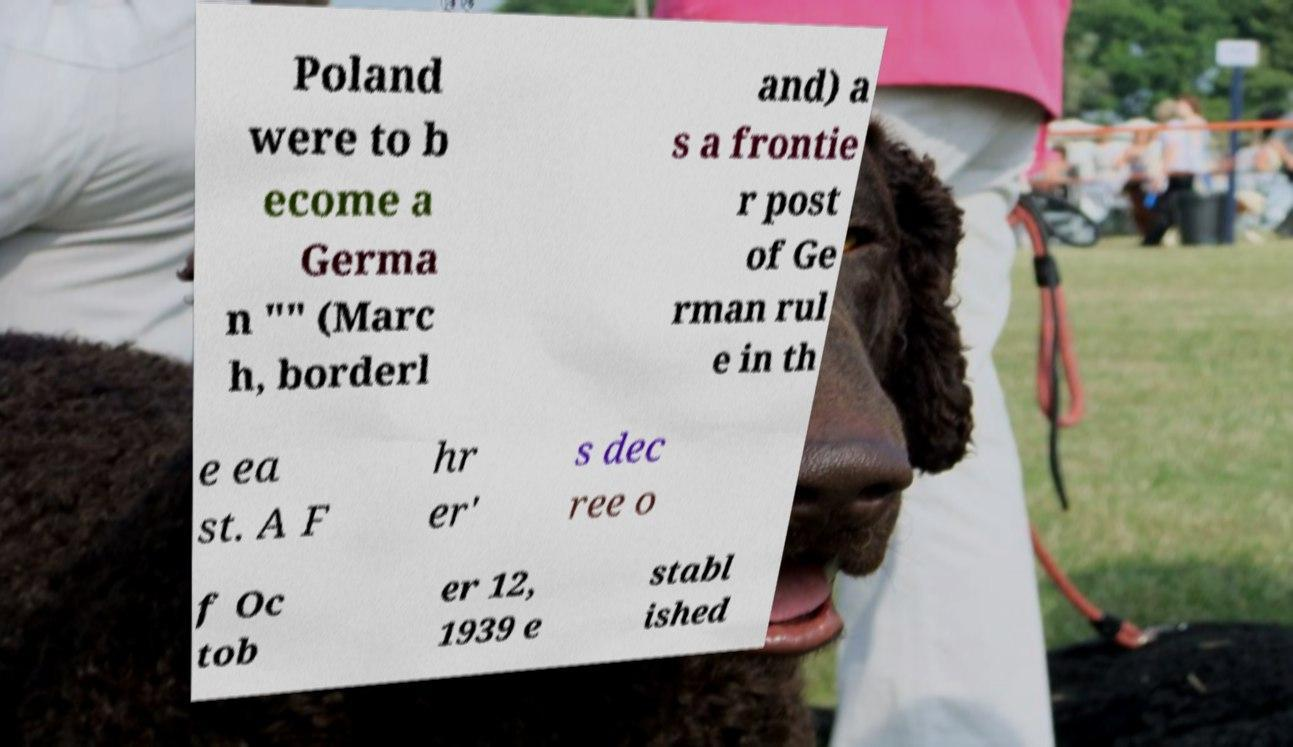Please read and relay the text visible in this image. What does it say? Poland were to b ecome a Germa n "" (Marc h, borderl and) a s a frontie r post of Ge rman rul e in th e ea st. A F hr er' s dec ree o f Oc tob er 12, 1939 e stabl ished 